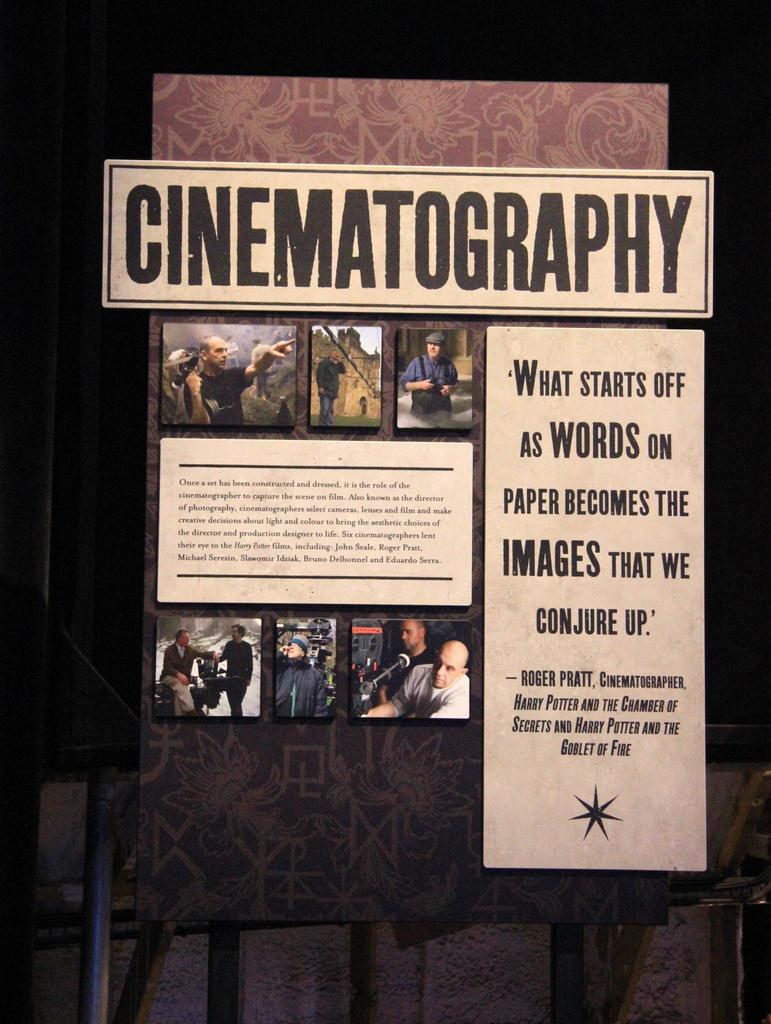What is the main object in the center of the image? There is a board in the center of the image. What can be seen at the bottom of the image? There is a fence at the bottom of the image. What type of stew is being prepared on the board in the image? There is no stew present in the image; it only features a board and a fence. How does the beginner's skill level affect the fence in the image? There is no indication of a beginner or skill level in the image, and the fence is not affected by any skill level. 